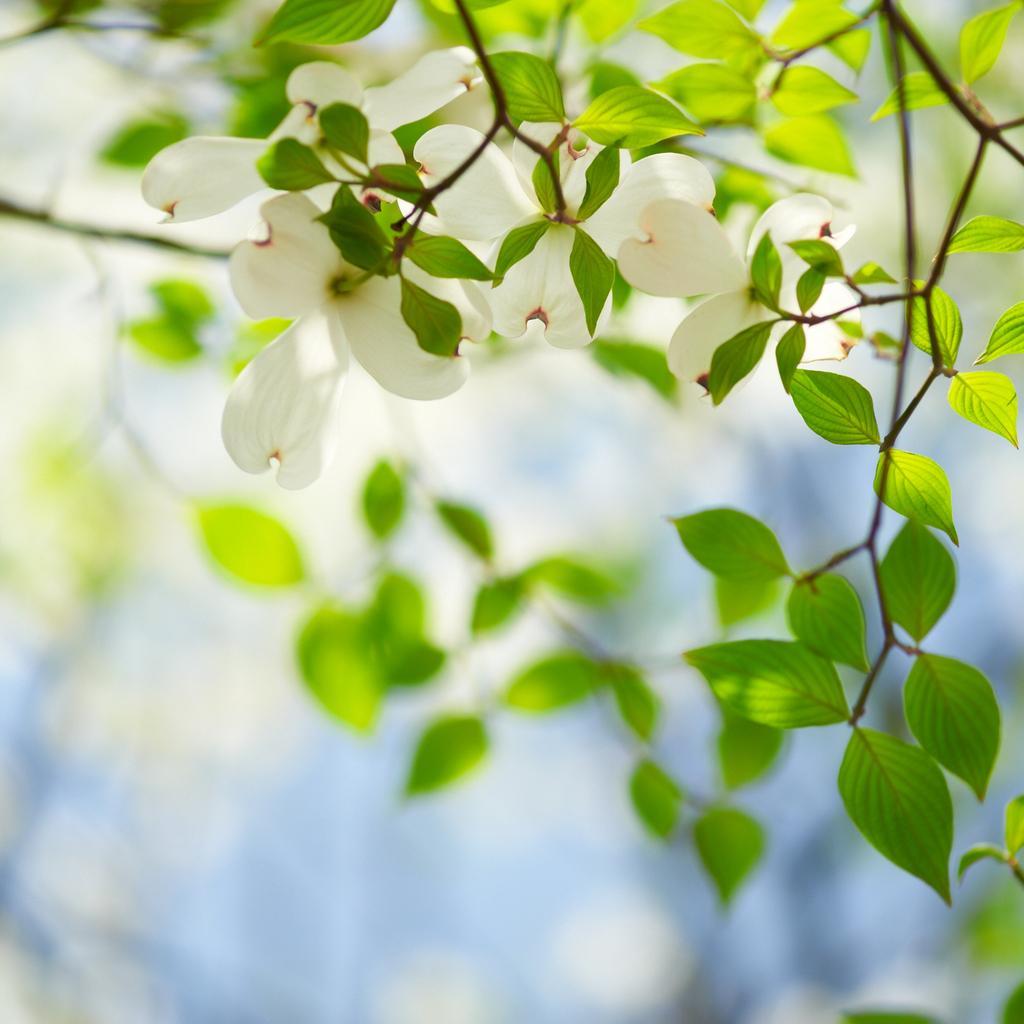Please provide a concise description of this image. In this image I can see there are beautiful white color flowers and green leaves of a tree. 